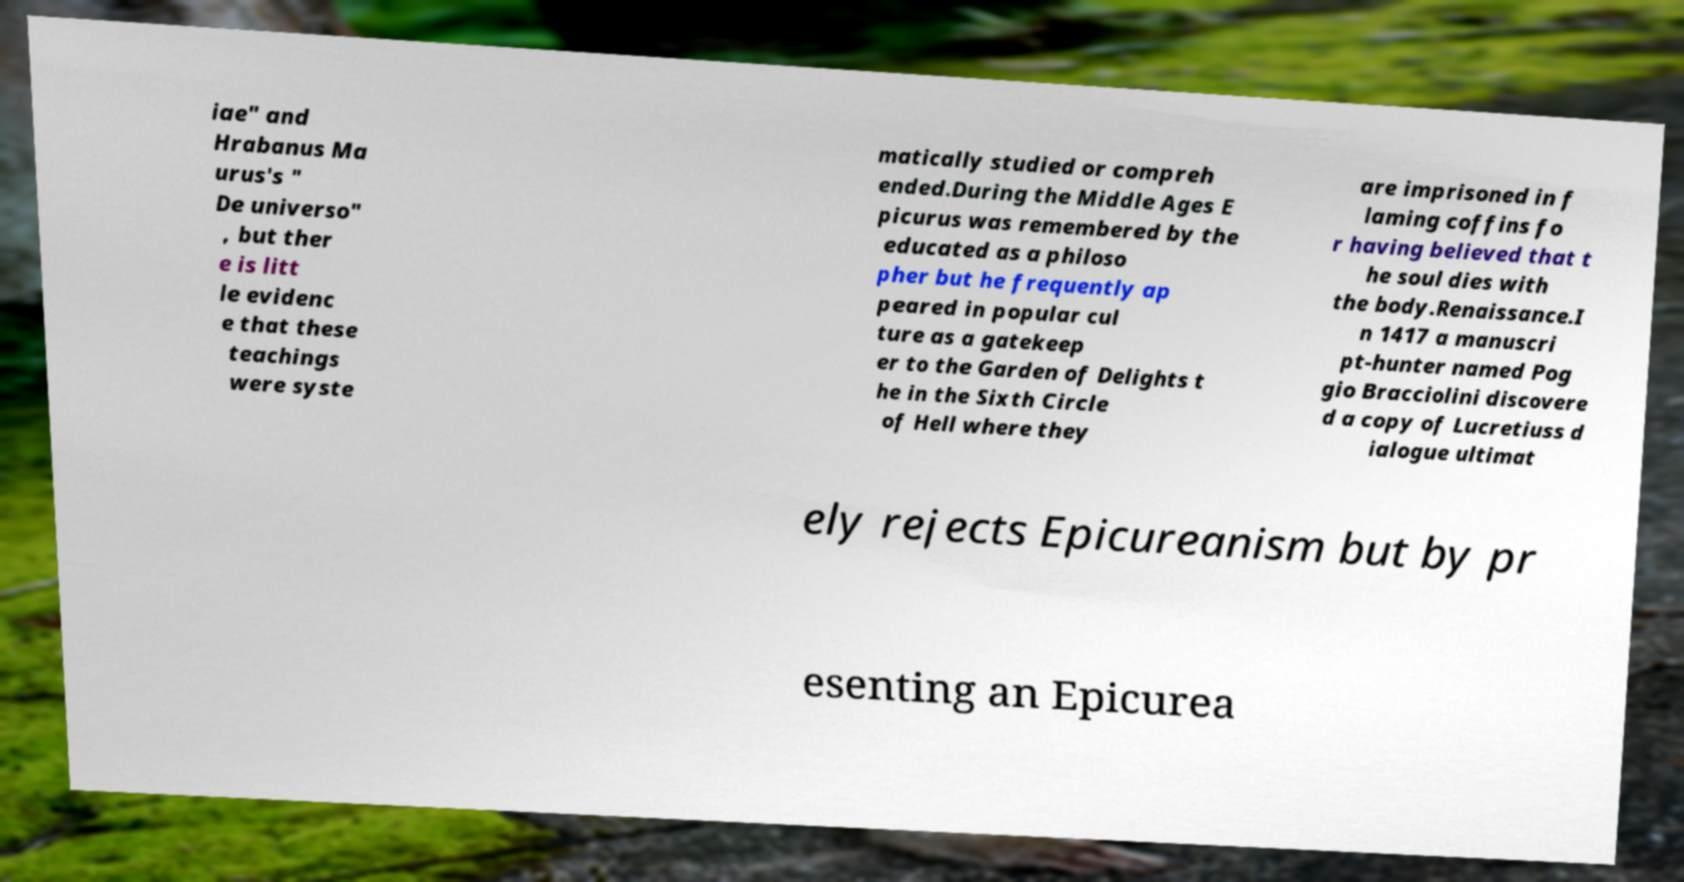Can you read and provide the text displayed in the image?This photo seems to have some interesting text. Can you extract and type it out for me? iae" and Hrabanus Ma urus's " De universo" , but ther e is litt le evidenc e that these teachings were syste matically studied or compreh ended.During the Middle Ages E picurus was remembered by the educated as a philoso pher but he frequently ap peared in popular cul ture as a gatekeep er to the Garden of Delights t he in the Sixth Circle of Hell where they are imprisoned in f laming coffins fo r having believed that t he soul dies with the body.Renaissance.I n 1417 a manuscri pt-hunter named Pog gio Bracciolini discovere d a copy of Lucretiuss d ialogue ultimat ely rejects Epicureanism but by pr esenting an Epicurea 